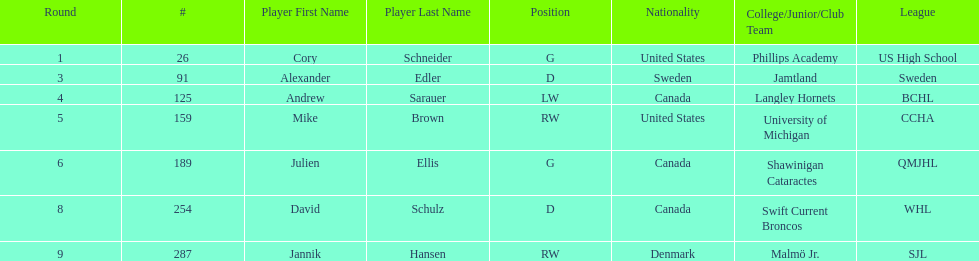How many goalies drafted? 2. 